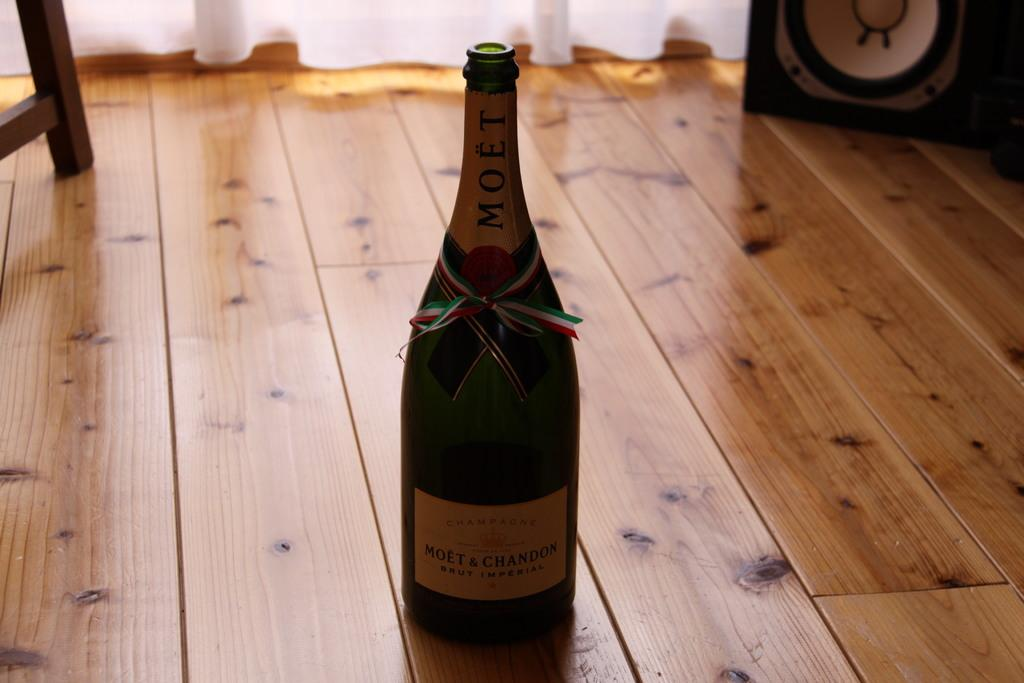<image>
Offer a succinct explanation of the picture presented. Bottle of Moet & Chandon wine is on a wooden floor. 